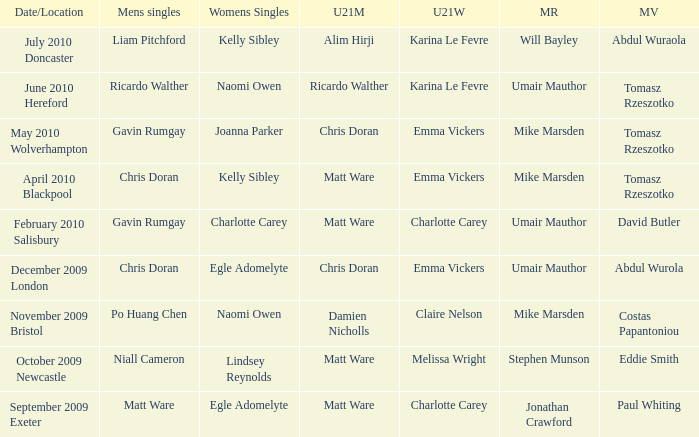Who won the mixed restricted when Tomasz Rzeszotko won the mixed veteran and Karina Le Fevre won the U21 womens? Umair Mauthor. 